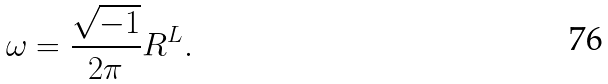<formula> <loc_0><loc_0><loc_500><loc_500>\omega = \frac { \sqrt { - 1 } } { 2 \pi } R ^ { L } .</formula> 